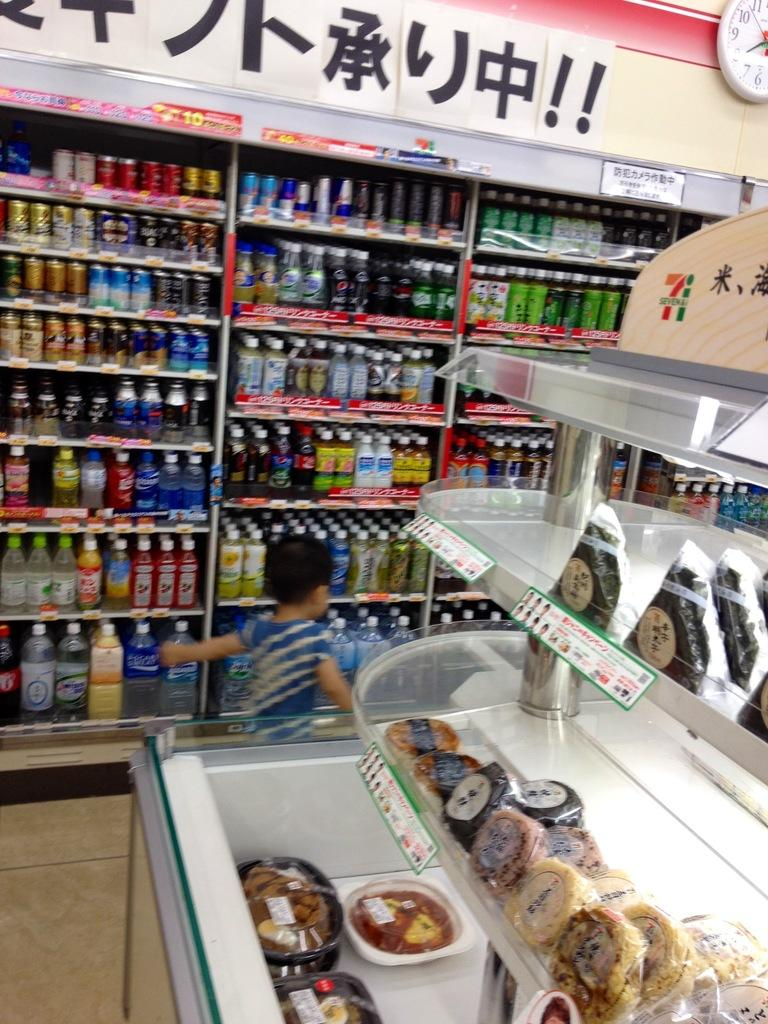Provide a one-sentence caption for the provided image. A child in a convience store and a clock on a wall showing the time of 8. 